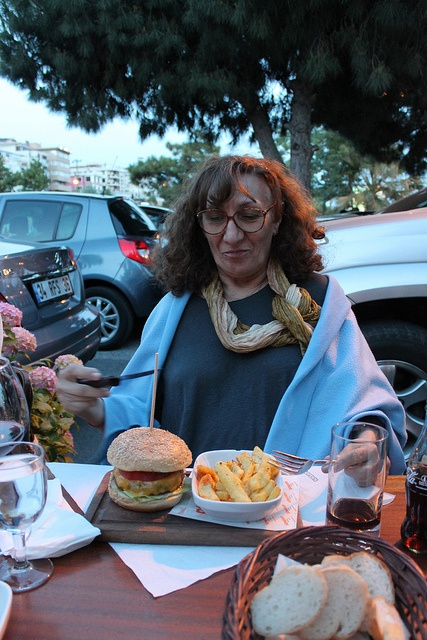Describe the objects in this image and their specific colors. I can see people in lightblue, black, gray, and navy tones, dining table in lightblue, gray, and lavender tones, bowl in lightblue, darkgray, black, gray, and maroon tones, truck in lightblue, black, and gray tones, and car in lightblue, black, and teal tones in this image. 